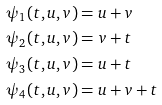<formula> <loc_0><loc_0><loc_500><loc_500>\psi _ { 1 } ( t , u , v ) & = u + v \\ \psi _ { 2 } ( t , u , v ) & = v + t \\ \psi _ { 3 } ( t , u , v ) & = u + t \\ \psi _ { 4 } ( t , u , v ) & = u + v + t</formula> 